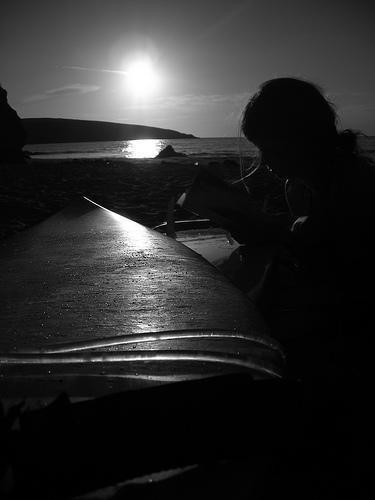What is the dominant weather condition depicted in the image? The weather is sunny with a few thin clouds in the sky. How does the image make you feel, and what contributes to that feeling? The image feels serene and peaceful, due to the calm beach setting, girl enjoying the sun, and the sun setting over the water. What type of landform can be seen across the water, and how does it affect the image? A mountain can be seen across the water, adding depth and a scenic backdrop to the image. List five objects that can be found in the image. Woman, surfboard, book, sun, mountain Mention a few notable details about the sun and its effect on the scene. The sun is shining brightly, about to set, and creating reflections on the water and the surfboard near the girl. Please detail an interaction happening between two objects in the picture. The sun's reflection is visible on the water, creating a bright and visually appealing effect in the scene. Briefly explain what the setting of the image is. The image is set on a sandy beach at sunset with a woman, surfboards, and a mountain across the water. In one sentence, describe the activity of the person in the image. The woman is sitting on the beach, enjoying the sun and reading a book near her surfboard. Explain the relationship between the woman and the surfboard in the image. The woman is likely a surfer or a beach enthusiast, as she is sitting on the beach with her surfboard nearby, enjoying the sun and reading a book. Identify three objects found in the picture and their relation. A woman is sitting near her surfboard and reading a book on the beach while the sun reflects on the water. 